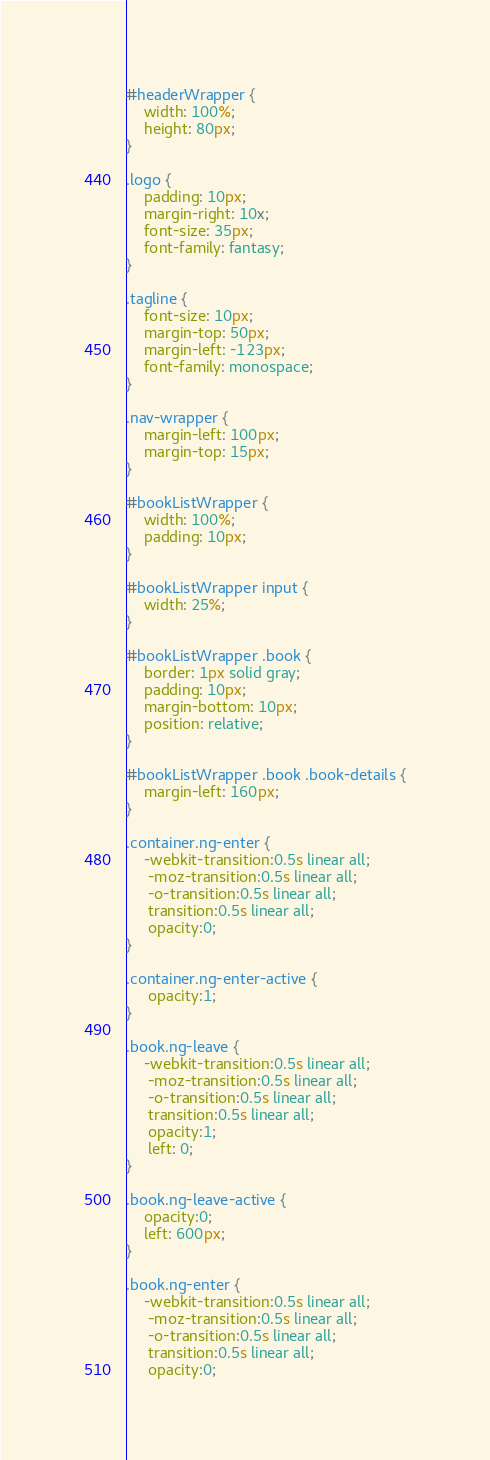Convert code to text. <code><loc_0><loc_0><loc_500><loc_500><_CSS_>#headerWrapper {
    width: 100%;
	height: 80px;
}

.logo {
    padding: 10px;
    margin-right: 10x;
    font-size: 35px;
    font-family: fantasy;
}

.tagline {
    font-size: 10px;
    margin-top: 50px;
    margin-left: -123px;
    font-family: monospace;
}

.nav-wrapper {
    margin-left: 100px;
    margin-top: 15px;
}

#bookListWrapper {
	width: 100%;
	padding: 10px;
}

#bookListWrapper input {
	width: 25%;
}

#bookListWrapper .book {
	border: 1px solid gray;
	padding: 10px;
	margin-bottom: 10px;	
	position: relative;
}

#bookListWrapper .book .book-details {
	margin-left: 160px;
}

.container.ng-enter {
	-webkit-transition:0.5s linear all;
	 -moz-transition:0.5s linear all;
	 -o-transition:0.5s linear all;
	 transition:0.5s linear all;
	 opacity:0;
}

.container.ng-enter-active {
	 opacity:1;
}

.book.ng-leave {
	-webkit-transition:0.5s linear all;
	 -moz-transition:0.5s linear all;
	 -o-transition:0.5s linear all;
	 transition:0.5s linear all;
	 opacity:1;
	 left: 0;
}

.book.ng-leave-active {
	opacity:0;
	left: 600px;
}

.book.ng-enter {
	-webkit-transition:0.5s linear all;
	 -moz-transition:0.5s linear all;
	 -o-transition:0.5s linear all;
	 transition:0.5s linear all;
	 opacity:0;</code> 